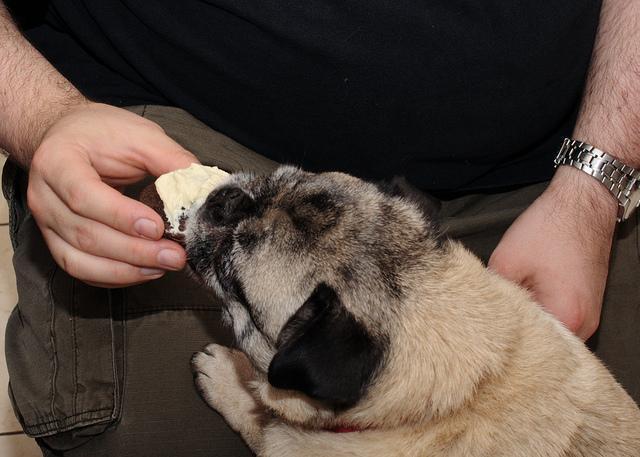How many people are in the picture?
Give a very brief answer. 2. 